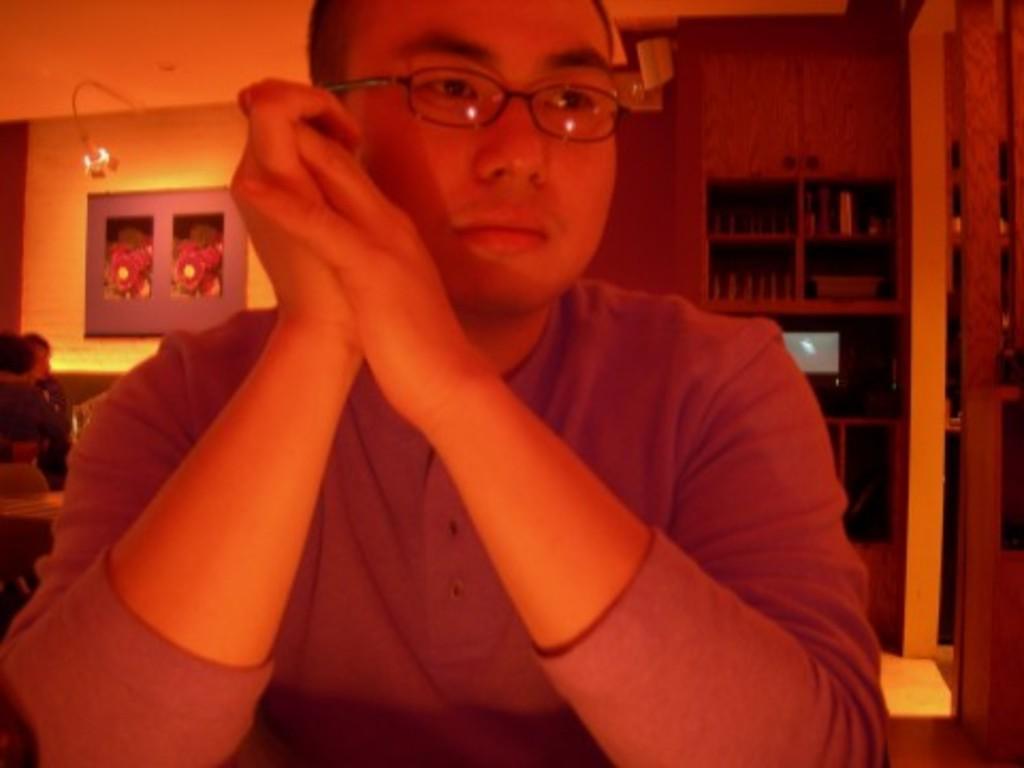In one or two sentences, can you explain what this image depicts? In the foreground I can see a person. In the background I can see shelves, wall painting on a wall and two persons are sitting on the chairs in front of a table. This image is taken may be in a hotel. 